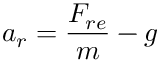<formula> <loc_0><loc_0><loc_500><loc_500>a _ { r } = \frac { F _ { r e } } { m } - g</formula> 